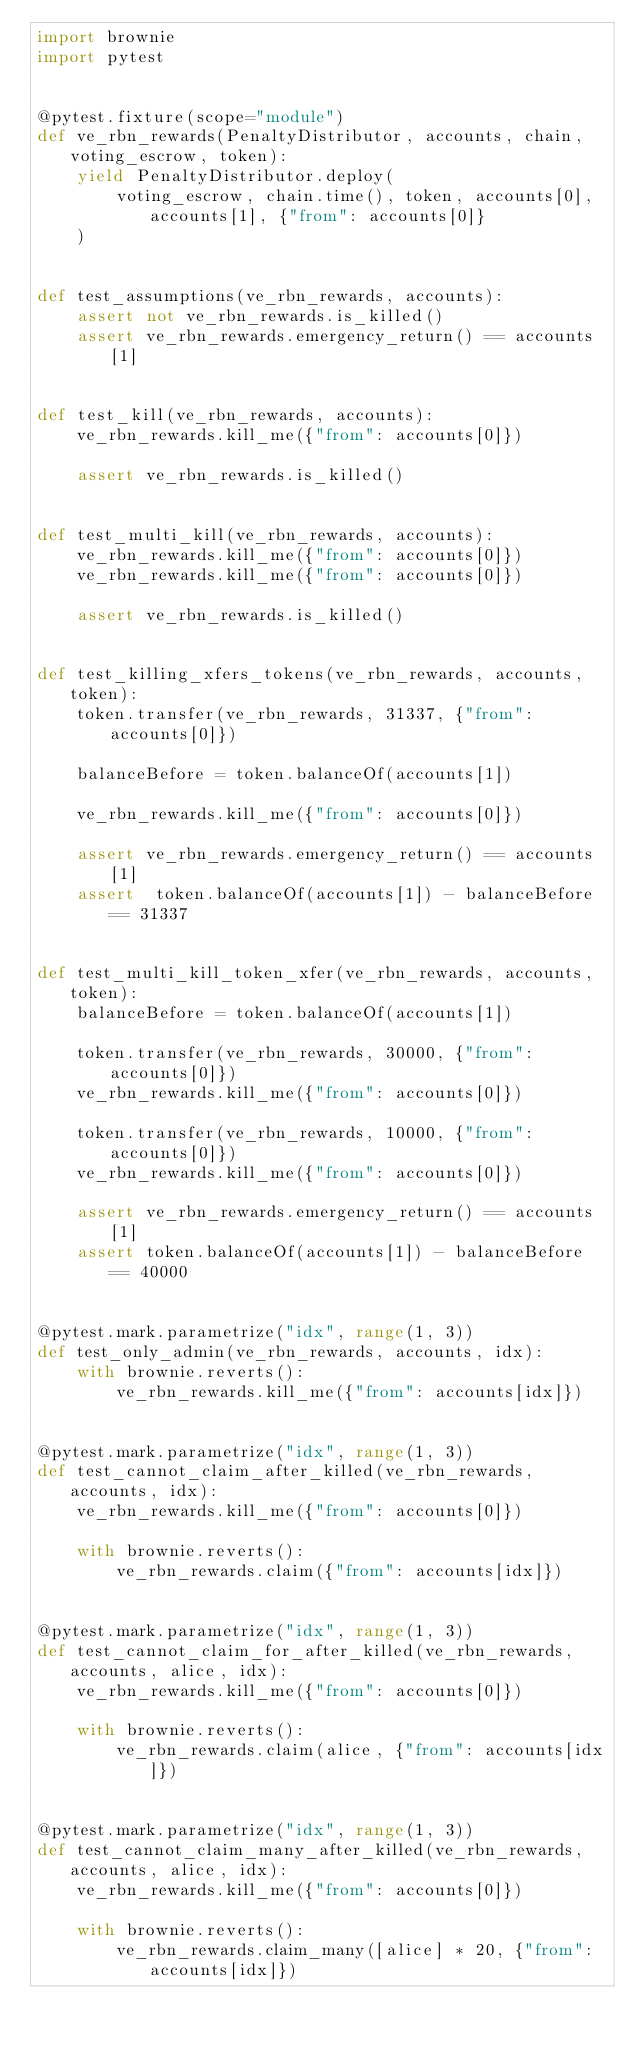<code> <loc_0><loc_0><loc_500><loc_500><_Python_>import brownie
import pytest


@pytest.fixture(scope="module")
def ve_rbn_rewards(PenaltyDistributor, accounts, chain, voting_escrow, token):
    yield PenaltyDistributor.deploy(
        voting_escrow, chain.time(), token, accounts[0], accounts[1], {"from": accounts[0]}
    )


def test_assumptions(ve_rbn_rewards, accounts):
    assert not ve_rbn_rewards.is_killed()
    assert ve_rbn_rewards.emergency_return() == accounts[1]


def test_kill(ve_rbn_rewards, accounts):
    ve_rbn_rewards.kill_me({"from": accounts[0]})

    assert ve_rbn_rewards.is_killed()


def test_multi_kill(ve_rbn_rewards, accounts):
    ve_rbn_rewards.kill_me({"from": accounts[0]})
    ve_rbn_rewards.kill_me({"from": accounts[0]})

    assert ve_rbn_rewards.is_killed()


def test_killing_xfers_tokens(ve_rbn_rewards, accounts, token):
    token.transfer(ve_rbn_rewards, 31337, {"from": accounts[0]})

    balanceBefore = token.balanceOf(accounts[1])

    ve_rbn_rewards.kill_me({"from": accounts[0]})

    assert ve_rbn_rewards.emergency_return() == accounts[1]
    assert  token.balanceOf(accounts[1]) - balanceBefore == 31337


def test_multi_kill_token_xfer(ve_rbn_rewards, accounts, token):
    balanceBefore = token.balanceOf(accounts[1])

    token.transfer(ve_rbn_rewards, 30000, {"from": accounts[0]})
    ve_rbn_rewards.kill_me({"from": accounts[0]})

    token.transfer(ve_rbn_rewards, 10000, {"from": accounts[0]})
    ve_rbn_rewards.kill_me({"from": accounts[0]})

    assert ve_rbn_rewards.emergency_return() == accounts[1]
    assert token.balanceOf(accounts[1]) - balanceBefore == 40000


@pytest.mark.parametrize("idx", range(1, 3))
def test_only_admin(ve_rbn_rewards, accounts, idx):
    with brownie.reverts():
        ve_rbn_rewards.kill_me({"from": accounts[idx]})


@pytest.mark.parametrize("idx", range(1, 3))
def test_cannot_claim_after_killed(ve_rbn_rewards, accounts, idx):
    ve_rbn_rewards.kill_me({"from": accounts[0]})

    with brownie.reverts():
        ve_rbn_rewards.claim({"from": accounts[idx]})


@pytest.mark.parametrize("idx", range(1, 3))
def test_cannot_claim_for_after_killed(ve_rbn_rewards, accounts, alice, idx):
    ve_rbn_rewards.kill_me({"from": accounts[0]})

    with brownie.reverts():
        ve_rbn_rewards.claim(alice, {"from": accounts[idx]})


@pytest.mark.parametrize("idx", range(1, 3))
def test_cannot_claim_many_after_killed(ve_rbn_rewards, accounts, alice, idx):
    ve_rbn_rewards.kill_me({"from": accounts[0]})

    with brownie.reverts():
        ve_rbn_rewards.claim_many([alice] * 20, {"from": accounts[idx]})
</code> 